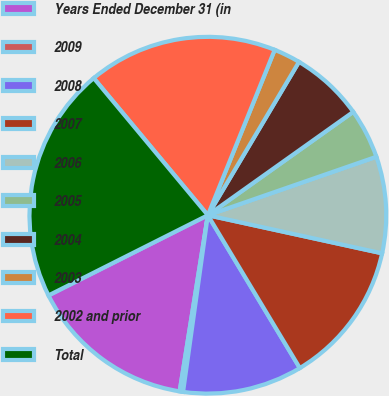Convert chart to OTSL. <chart><loc_0><loc_0><loc_500><loc_500><pie_chart><fcel>Years Ended December 31 (in<fcel>2009<fcel>2008<fcel>2007<fcel>2006<fcel>2005<fcel>2004<fcel>2003<fcel>2002 and prior<fcel>Total<nl><fcel>15.05%<fcel>0.31%<fcel>10.84%<fcel>12.95%<fcel>8.74%<fcel>4.52%<fcel>6.63%<fcel>2.42%<fcel>17.16%<fcel>21.37%<nl></chart> 